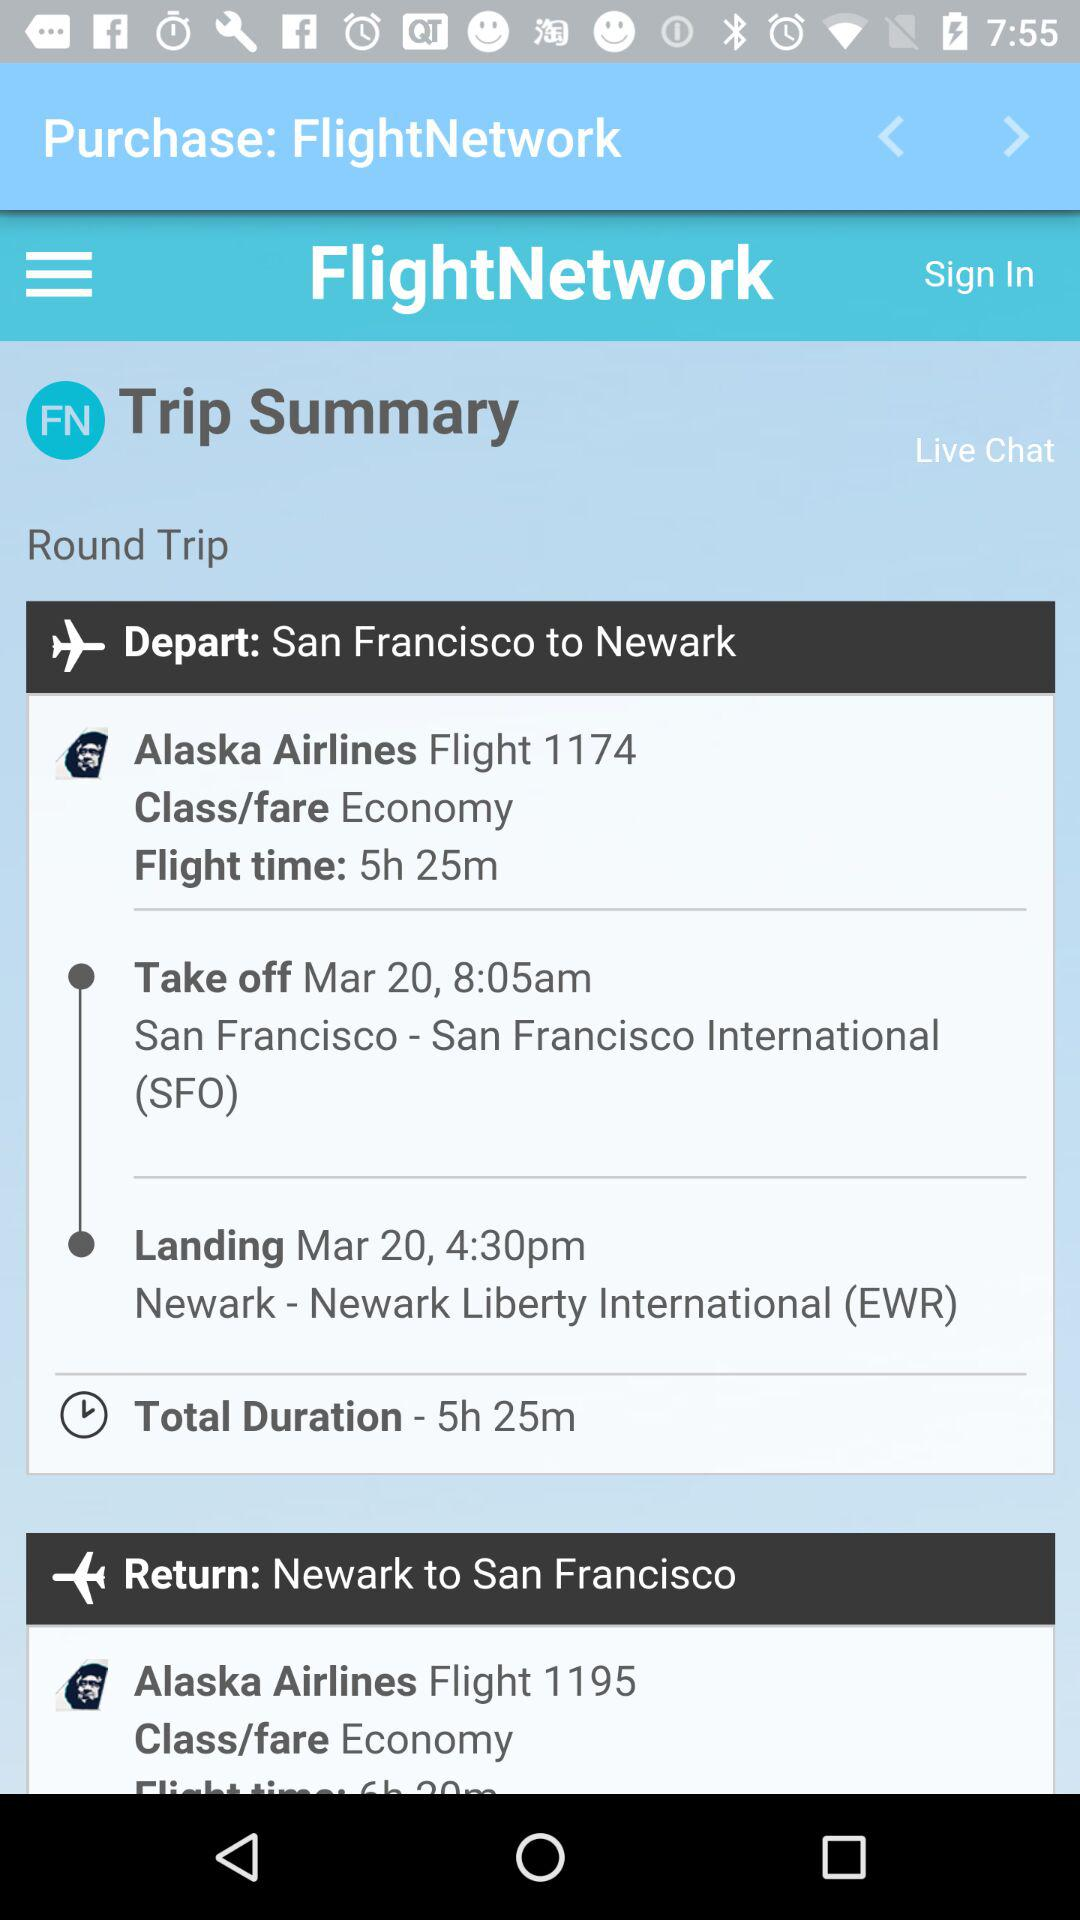How many hours and minutes is the total flight time?
Answer the question using a single word or phrase. 5h 25m 